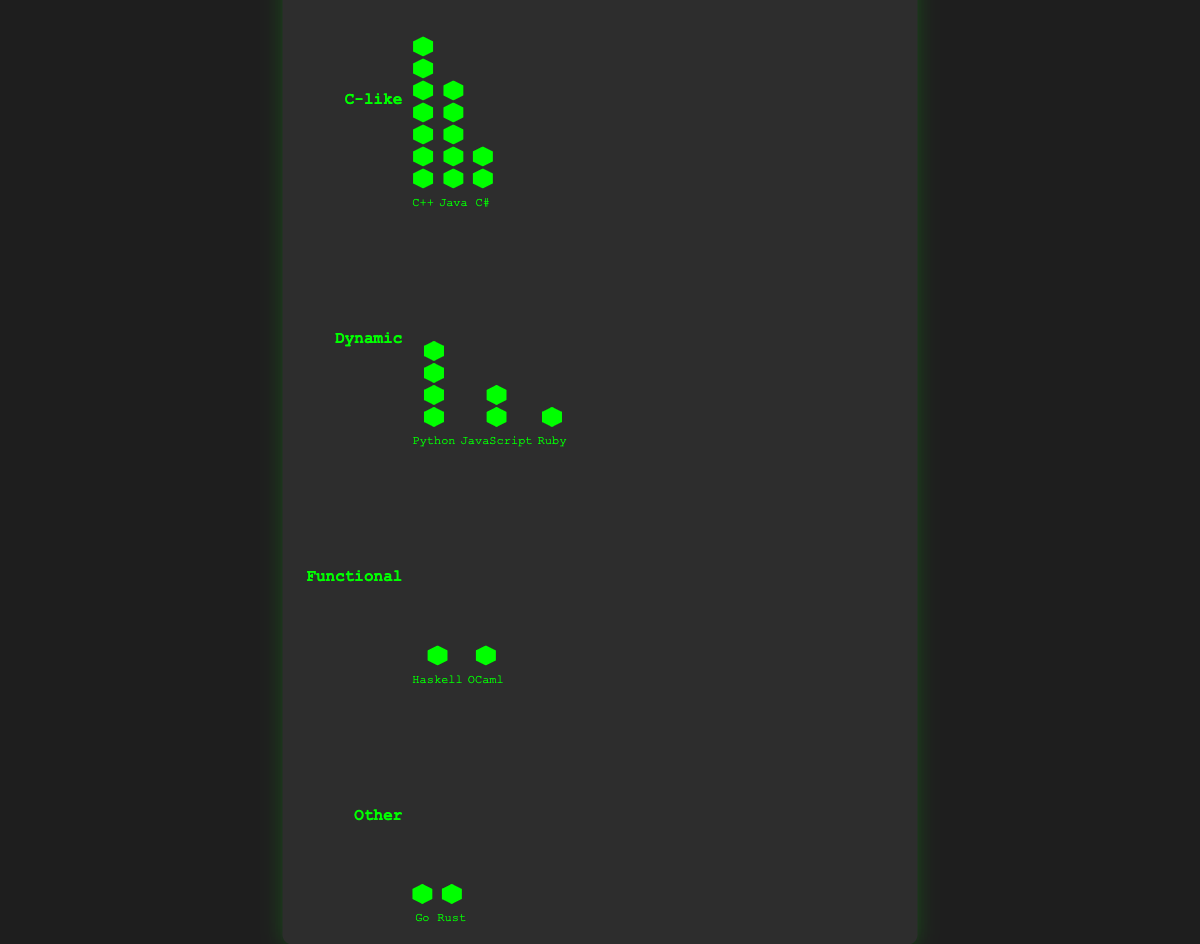What's the most popular programming language among competitive coders? The chart indicates that C++ has the highest number of icons in the "C-like" family. This shows that it is the most popular language.
Answer: C++ Which language family has the least number of languages? By referring to the chart, we see that the "Functional" family has only two languages, Haskell and OCaml, which is the least among all families.
Answer: Functional How many icons represent JavaScript? JavaScript, under the "Dynamic" family, is represented by 8 icons stacked vertically in the plot.
Answer: 8 Which language family has the lowest total popularity? The "Functional" family has 3 (Haskell) + 2 (OCaml) = 5, which is the lowest total popularity compared to the other families.
Answer: Functional Which language in the "Other" family is more popular? By comparing the number of icons for Go and Rust within the "Other" family, we see that Go has 4 icons while Rust has 3, making Go more popular.
Answer: Go What's the combined popularity of Python and Ruby? Python has 20 icons and Ruby has 2 icons under the "Dynamic" family. Adding them gives 20 + 2 = 22.
Answer: 22 Is Java more popular than JavaScript? Java in the "C-like" family has 25 icons, while JavaScript in the "Dynamic" family has 8 icons. 25 is greater than 8, so Java is more popular.
Answer: Yes Which language has the highest popularity in the "Dynamic" family? By looking at the icons within the "Dynamic" family, Python has the highest number of icons (20), making it the most popular.
Answer: Python What's the total number of languages represented in the chart? Summing up the languages by family: 3 (C-like) + 3 (Dynamic) + 2 (Functional) + 2 (Other) = 10 languages in total.
Answer: 10 How many families have a language popularity of 10 or more? Within the icons for each family, the "C-like" family has three languages (C++, Java, C#) and the "Dynamic" family has one language (Python) with a popularity of 10 or more, totaling 2 families.
Answer: 2 